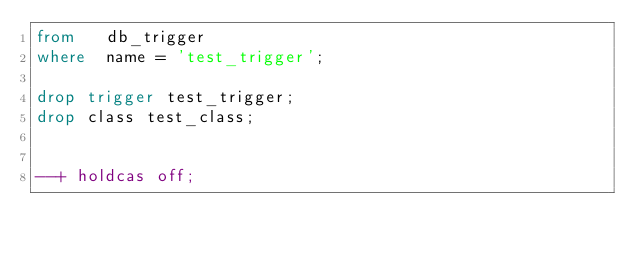<code> <loc_0><loc_0><loc_500><loc_500><_SQL_>from   db_trigger
where  name = 'test_trigger';

drop trigger test_trigger;
drop class test_class;


--+ holdcas off;
</code> 